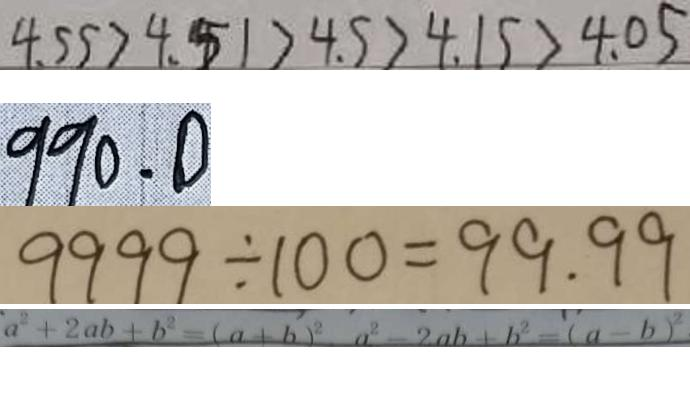<formula> <loc_0><loc_0><loc_500><loc_500>4 . 5 5 > 4 . 5 1 > 4 . 5 > 4 . 1 5 > 4 . 0 5 
 9 9 0 . 0 
 9 9 9 9 \div 1 0 0 = 9 9 . 9 9 
 a ^ { 2 } + 2 a b + b ^ { 2 } = ( a + b ) ^ { 2 } a ^ { 2 } - 2 a b + b ^ { 2 } = ( a - b ) ^ { 2 }</formula> 